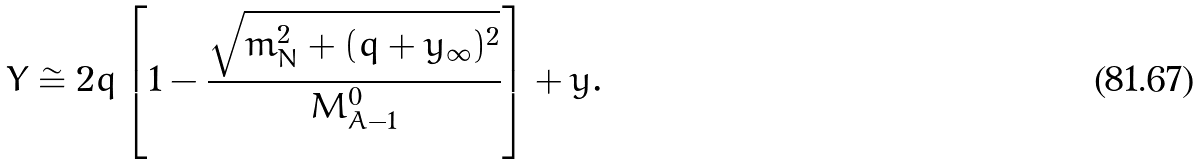<formula> <loc_0><loc_0><loc_500><loc_500>Y \cong 2 q \left [ 1 - \frac { \sqrt { m _ { N } ^ { 2 } + ( q + y _ { \infty } ) ^ { 2 } } } { M _ { A - 1 } ^ { 0 } } \right ] + y .</formula> 